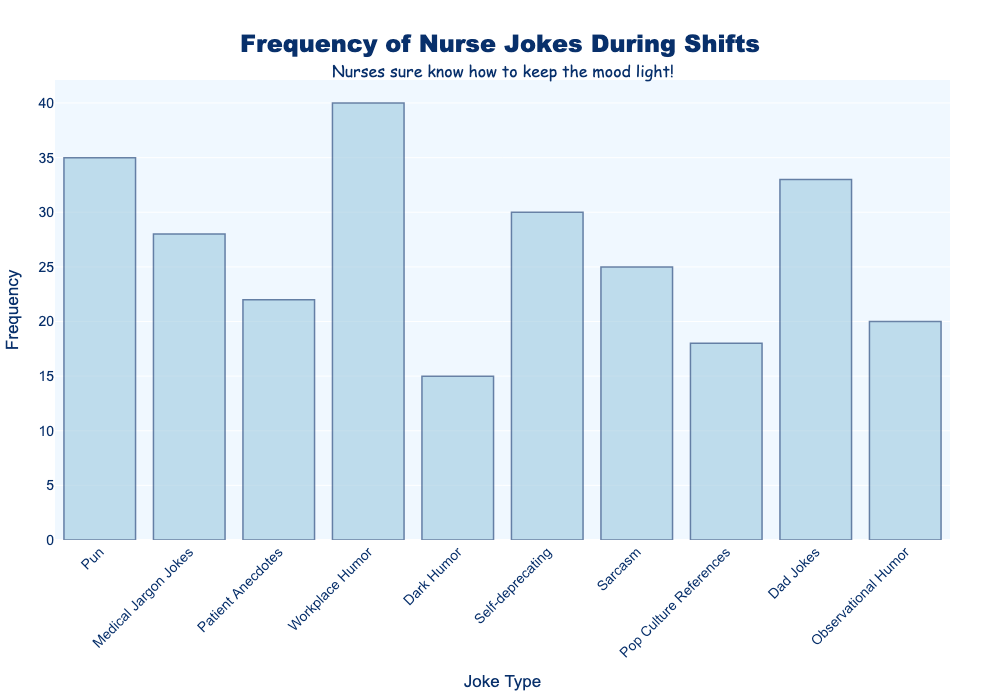What's the highest frequency of jokes? To find the highest frequency, look at the y-values for each joke type and identify the maximum y-value. The highest frequency is 40.
Answer: 40 Which joke type has the lowest frequency? To find the joke type with the lowest frequency, look at the y-values for each joke type and identify the minimum y-value. Dark Humor has the lowest frequency with 15.
Answer: Dark Humor How many more 'Workplace Humor' jokes are there compared to 'Dark Humor' jokes? Find the difference between the frequencies of 'Workplace Humor' and 'Dark Humor'. Workplace Humor has 40 and Dark Humor has 15, so the difference is 40 - 15 = 25.
Answer: 25 What is the total frequency of jokes that have a frequency of 30 or more? Add up the frequencies of all joke types that have a frequency of 30 or more. These are: Pun (35), Workplace Humor (40), Self-deprecating (30), and Dad Jokes (33). Their total frequency is 35 + 40 + 30 + 33 = 138.
Answer: 138 What is the average frequency of jokes? Sum all the frequencies and divide by the number of joke types. The total frequency is 266 and there are 10 joke types. So, the average frequency is 266 / 10 = 26.6.
Answer: 26.6 Which joke type has a frequency closest to the average frequency of all jokes? First, find the average frequency, which is 26.6. Then, check which joke type has a frequency closest to this value. Self-deprecating jokes have a frequency of 30, which is closest to 26.6.
Answer: Self-deprecating How does the frequency of 'Medical Jargon Jokes' compare to 'Sarcasm'? Compare the y-values for 'Medical Jargon Jokes' and 'Sarcasm'. 'Medical Jargon Jokes' have a frequency of 28, and 'Sarcasm' has a frequency of 25. 'Medical Jargon Jokes' are slightly more frequent.
Answer: Medical Jargon Jokes > Sarcasm What is the frequency range of jokes? To find the range, subtract the smallest frequency from the largest frequency. The smallest frequency is 15 (Dark Humor) and the largest is 40 (Workplace Humor). So, the range is 40 - 15 = 25.
Answer: 25 